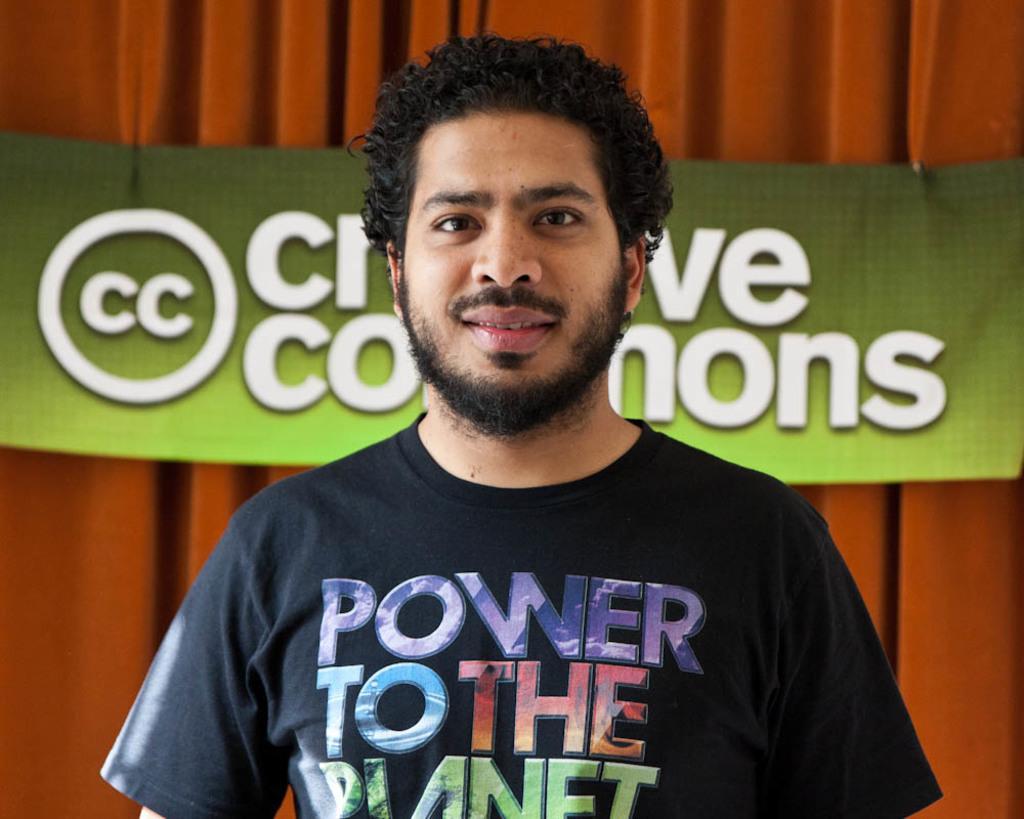Describe this image in one or two sentences. Here I can see a man wearing a t-shirt, smiling and giving pose for the picture. In the background there is a curtain and also I can see a green color banner on which I can see some text. 